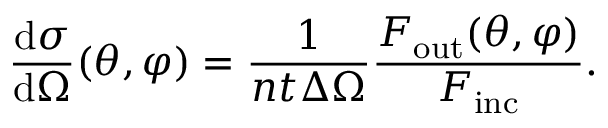Convert formula to latex. <formula><loc_0><loc_0><loc_500><loc_500>{ \frac { d \sigma } { d \Omega } } ( \theta , \varphi ) = { \frac { 1 } { n t \Delta \Omega } } { \frac { F _ { o u t } ( \theta , \varphi ) } { F _ { i n c } } } .</formula> 